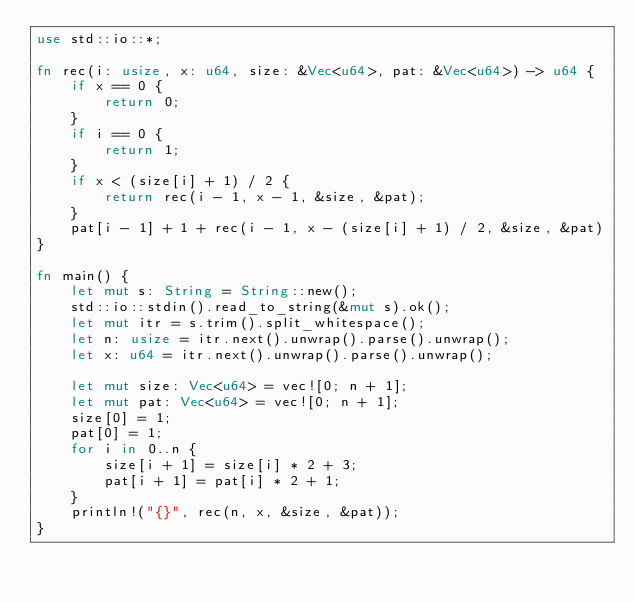<code> <loc_0><loc_0><loc_500><loc_500><_Rust_>use std::io::*;

fn rec(i: usize, x: u64, size: &Vec<u64>, pat: &Vec<u64>) -> u64 {
    if x == 0 {
        return 0;
    }
    if i == 0 {
        return 1;
    }
    if x < (size[i] + 1) / 2 {
        return rec(i - 1, x - 1, &size, &pat);
    }
    pat[i - 1] + 1 + rec(i - 1, x - (size[i] + 1) / 2, &size, &pat)
}

fn main() {
    let mut s: String = String::new();
    std::io::stdin().read_to_string(&mut s).ok();
    let mut itr = s.trim().split_whitespace();
    let n: usize = itr.next().unwrap().parse().unwrap();
    let x: u64 = itr.next().unwrap().parse().unwrap();

    let mut size: Vec<u64> = vec![0; n + 1];
    let mut pat: Vec<u64> = vec![0; n + 1];
    size[0] = 1;
    pat[0] = 1;
    for i in 0..n {
        size[i + 1] = size[i] * 2 + 3;
        pat[i + 1] = pat[i] * 2 + 1;
    }
    println!("{}", rec(n, x, &size, &pat));
}
</code> 